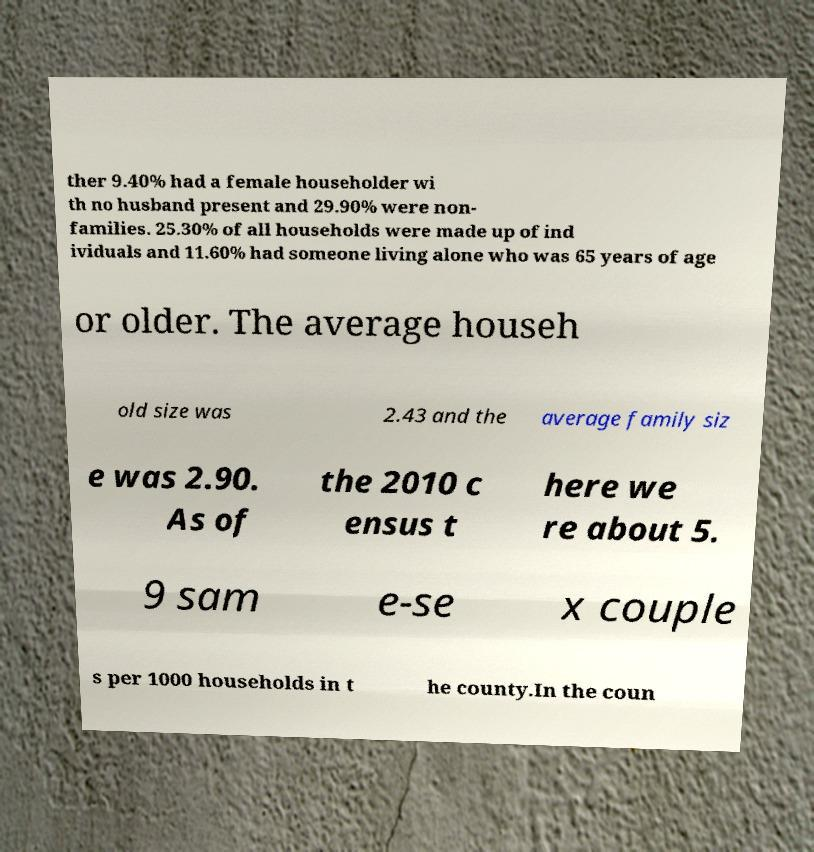Could you extract and type out the text from this image? ther 9.40% had a female householder wi th no husband present and 29.90% were non- families. 25.30% of all households were made up of ind ividuals and 11.60% had someone living alone who was 65 years of age or older. The average househ old size was 2.43 and the average family siz e was 2.90. As of the 2010 c ensus t here we re about 5. 9 sam e-se x couple s per 1000 households in t he county.In the coun 